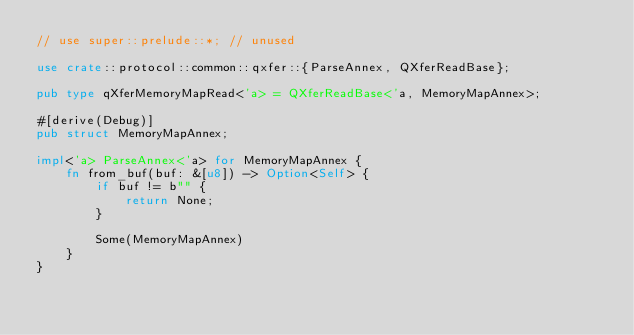Convert code to text. <code><loc_0><loc_0><loc_500><loc_500><_Rust_>// use super::prelude::*; // unused

use crate::protocol::common::qxfer::{ParseAnnex, QXferReadBase};

pub type qXferMemoryMapRead<'a> = QXferReadBase<'a, MemoryMapAnnex>;

#[derive(Debug)]
pub struct MemoryMapAnnex;

impl<'a> ParseAnnex<'a> for MemoryMapAnnex {
    fn from_buf(buf: &[u8]) -> Option<Self> {
        if buf != b"" {
            return None;
        }

        Some(MemoryMapAnnex)
    }
}
</code> 